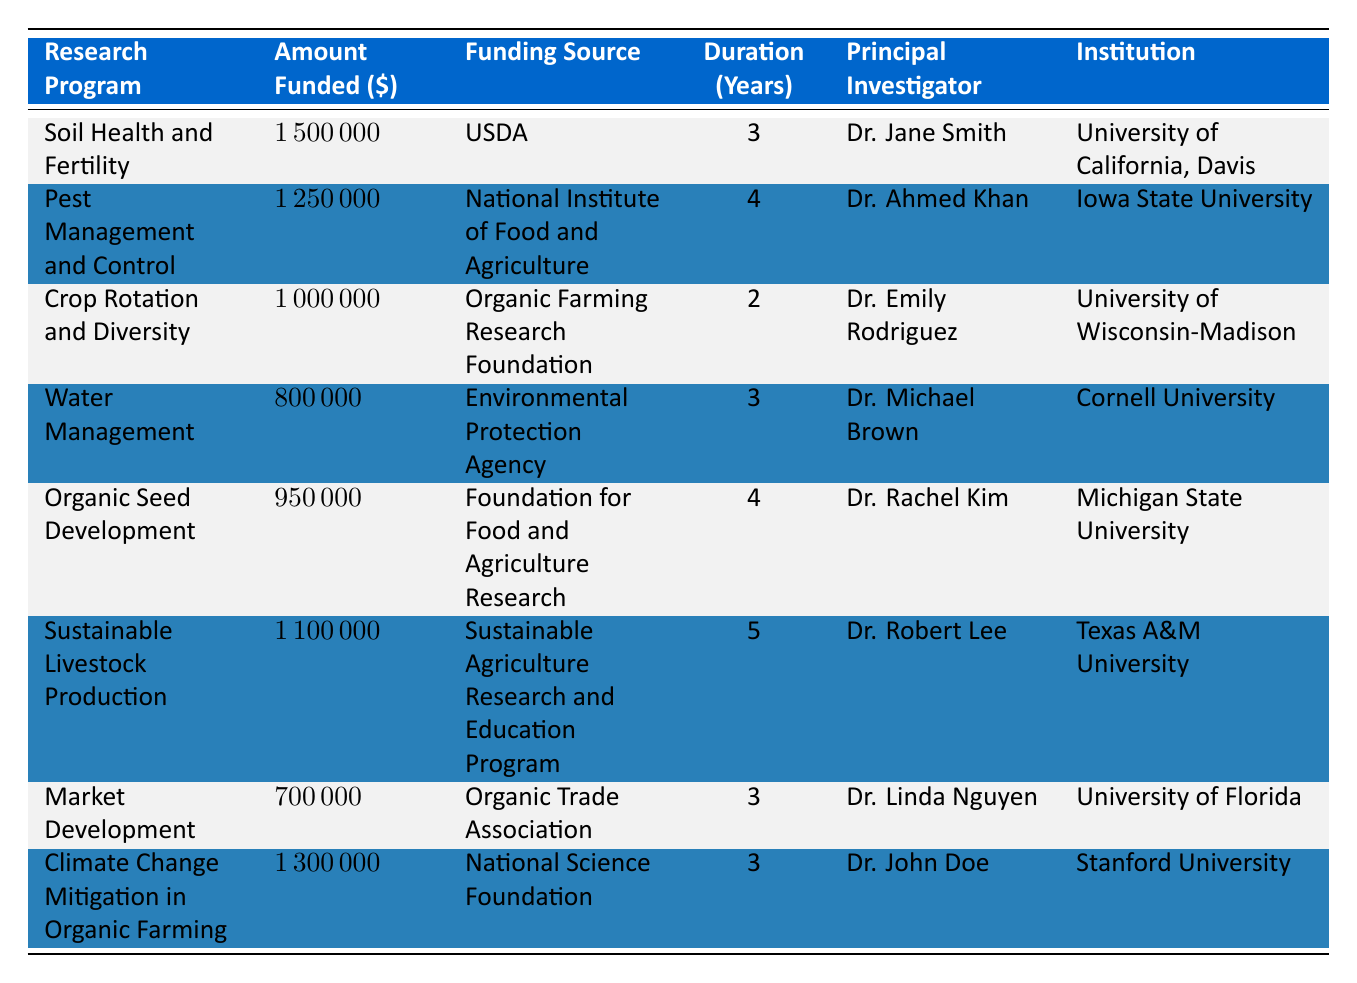What is the total amount funded for all research programs? To find the total amount funded, we sum up the amounts funded across all research programs: 1500000 + 1250000 + 1000000 + 800000 + 950000 + 1100000 + 700000 + 1300000 = 10300000.
Answer: 10300000 Which research program received the highest amount of funding? By comparing the amounts funded, the program with the highest amount is "Soil Health and Fertility," which received 1500000.
Answer: Soil Health and Fertility Is the "Market Development" program funded by the USDA? Looking at the funding source for "Market Development," it is actually funded by the "Organic Trade Association," not the USDA.
Answer: No How many programs have a duration of 4 years? Checking the duration for each program, there are two programs with a duration of 4 years: "Pest Management and Control" and "Organic Seed Development."
Answer: 2 What is the average funding amount for programs with a duration of 3 years? The programs with a duration of 3 years are "Soil Health and Fertility," "Water Management," "Market Development," and "Climate Change Mitigation in Organic Farming." Their funding amounts are: 1500000, 800000, 700000, and 1300000. Summing them gives 1500000 + 800000 + 700000 + 1300000 = 4300000. There are 4 programs, so the average is 4300000 / 4 = 1075000.
Answer: 1075000 Which institution is associated with the principal investigator Dr. Rachel Kim? Referring to the table, Dr. Rachel Kim is associated with "Michigan State University" for the program "Organic Seed Development."
Answer: Michigan State University 